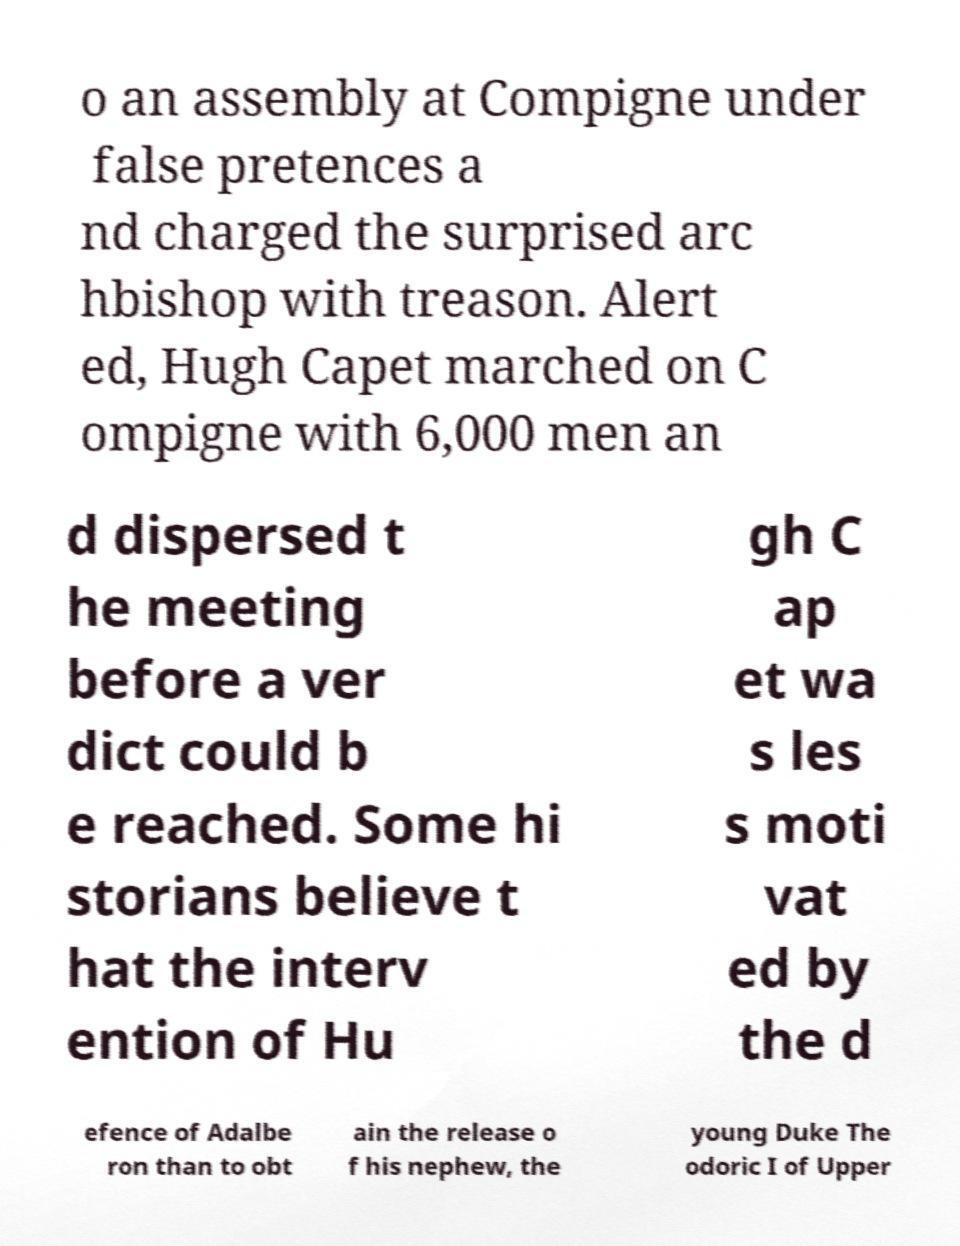Please read and relay the text visible in this image. What does it say? o an assembly at Compigne under false pretences a nd charged the surprised arc hbishop with treason. Alert ed, Hugh Capet marched on C ompigne with 6,000 men an d dispersed t he meeting before a ver dict could b e reached. Some hi storians believe t hat the interv ention of Hu gh C ap et wa s les s moti vat ed by the d efence of Adalbe ron than to obt ain the release o f his nephew, the young Duke The odoric I of Upper 